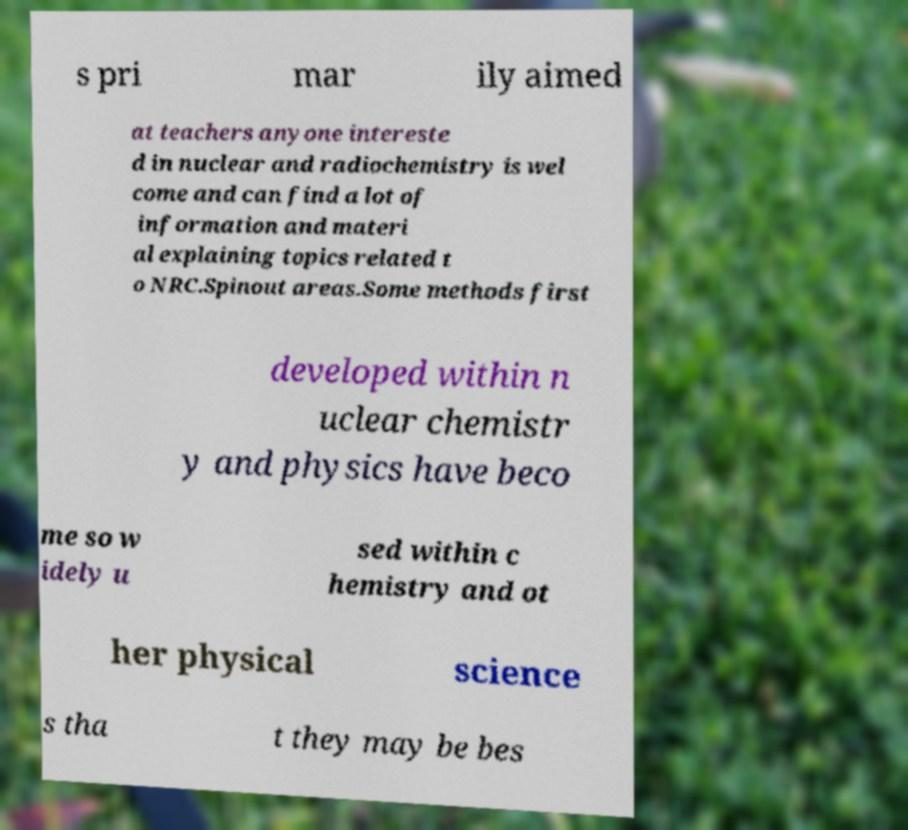For documentation purposes, I need the text within this image transcribed. Could you provide that? s pri mar ily aimed at teachers anyone intereste d in nuclear and radiochemistry is wel come and can find a lot of information and materi al explaining topics related t o NRC.Spinout areas.Some methods first developed within n uclear chemistr y and physics have beco me so w idely u sed within c hemistry and ot her physical science s tha t they may be bes 